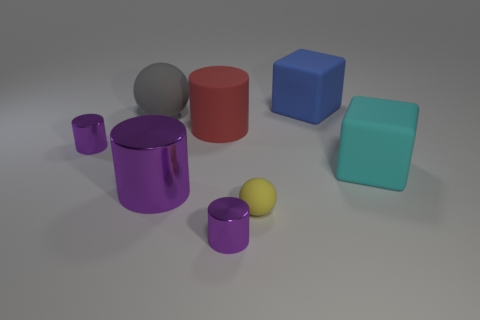Are there an equal number of cylinders that are in front of the big purple object and yellow spheres behind the gray sphere?
Provide a short and direct response. No. There is a small metal thing that is behind the small metal object in front of the tiny purple metallic object that is behind the tiny yellow sphere; what is its color?
Provide a short and direct response. Purple. What number of things are in front of the gray rubber ball and to the right of the tiny rubber sphere?
Provide a short and direct response. 1. Is the color of the metal cylinder that is in front of the yellow rubber sphere the same as the ball that is behind the cyan cube?
Give a very brief answer. No. What is the size of the cyan matte thing that is the same shape as the big blue rubber object?
Provide a short and direct response. Large. Are there any big blue blocks left of the big red rubber cylinder?
Your answer should be compact. No. Are there the same number of large matte cubes that are in front of the cyan cube and red rubber cylinders?
Your response must be concise. No. There is a small object to the left of the purple thing that is in front of the small yellow rubber thing; are there any purple things that are in front of it?
Make the answer very short. Yes. What material is the blue block?
Your answer should be very brief. Rubber. How many other things are the same shape as the big red rubber object?
Provide a succinct answer. 3. 